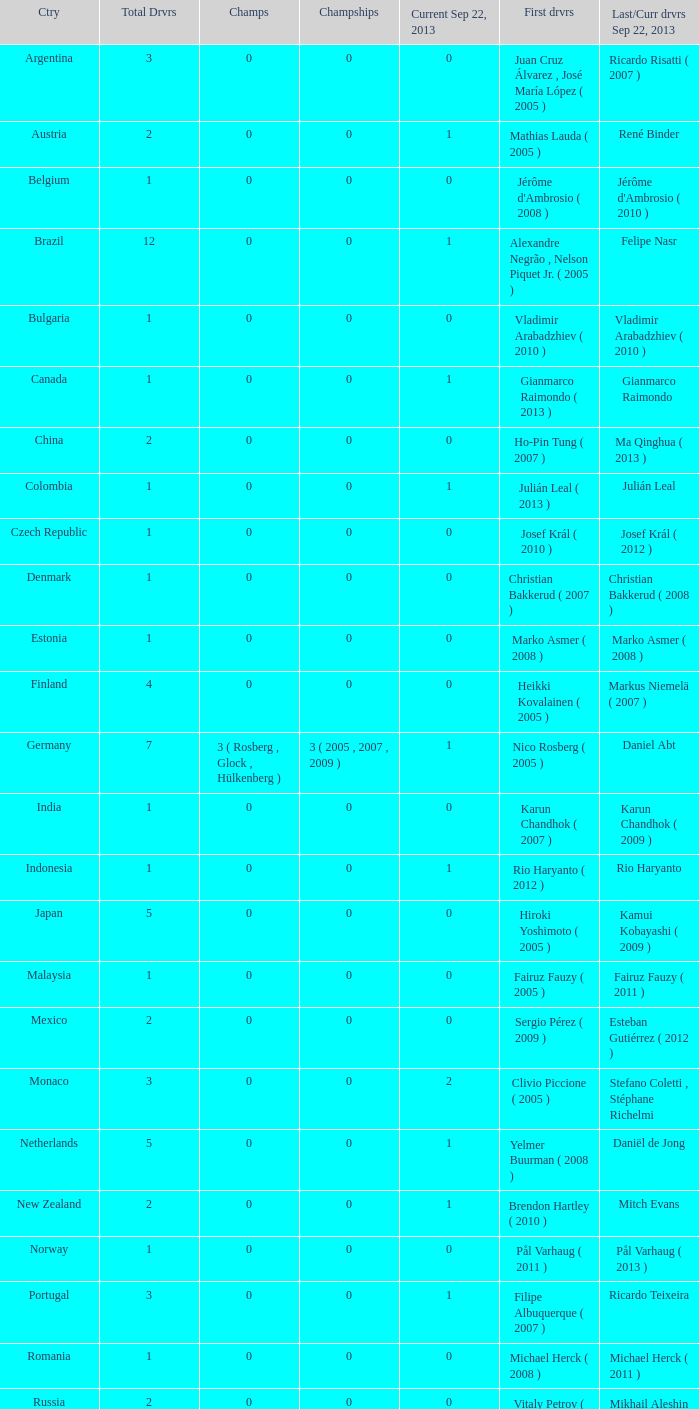How many champions were there when the last driver was Gianmarco Raimondo? 0.0. 